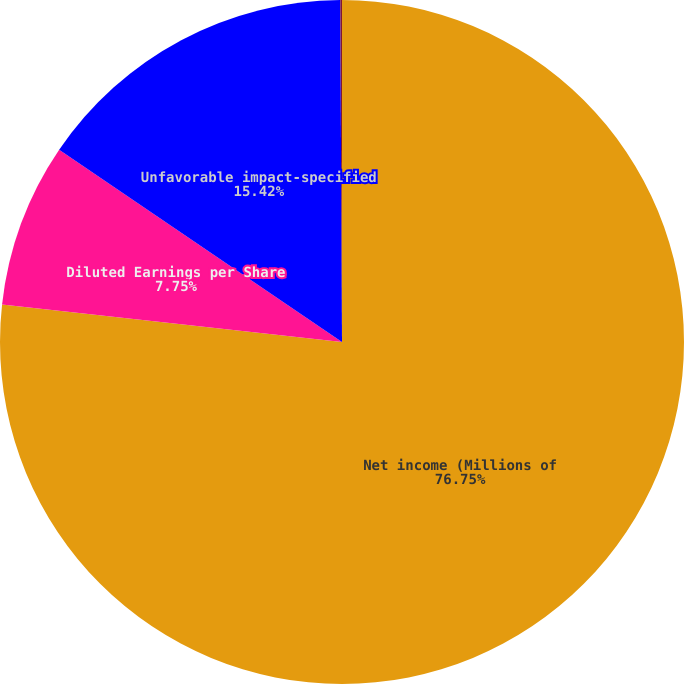<chart> <loc_0><loc_0><loc_500><loc_500><pie_chart><fcel>Net income (Millions of<fcel>Diluted Earnings per Share<fcel>Unfavorable impact-specified<fcel>Favorable (unfavorable)<nl><fcel>76.76%<fcel>7.75%<fcel>15.42%<fcel>0.08%<nl></chart> 